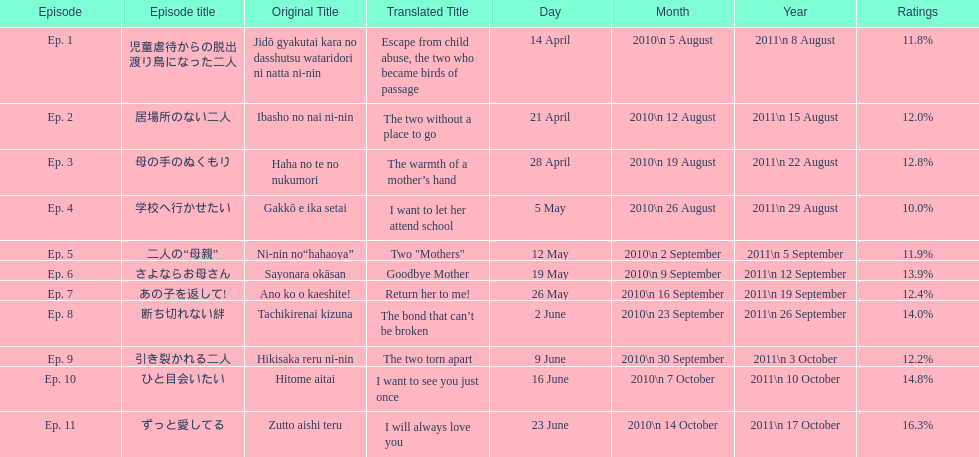What was the name of the first episode of this show? 児童虐待からの脱出 渡り鳥になった二人. 